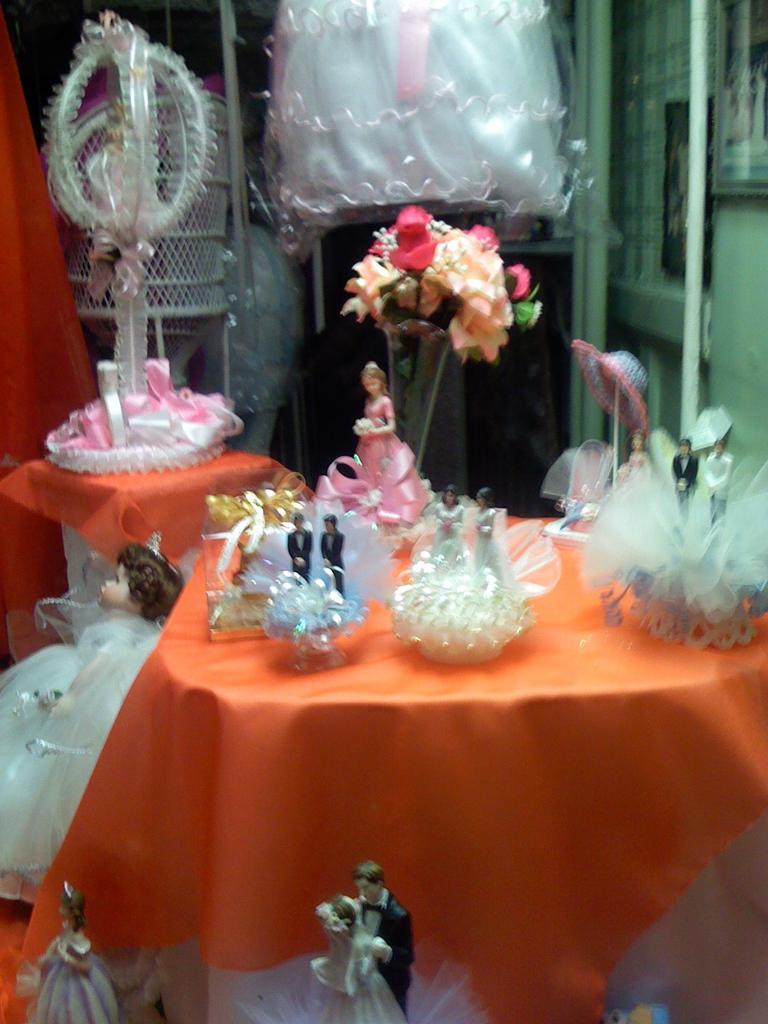Please provide a concise description of this image. In this image I see number of dolls which are colorful and I see few dogs on this table. 